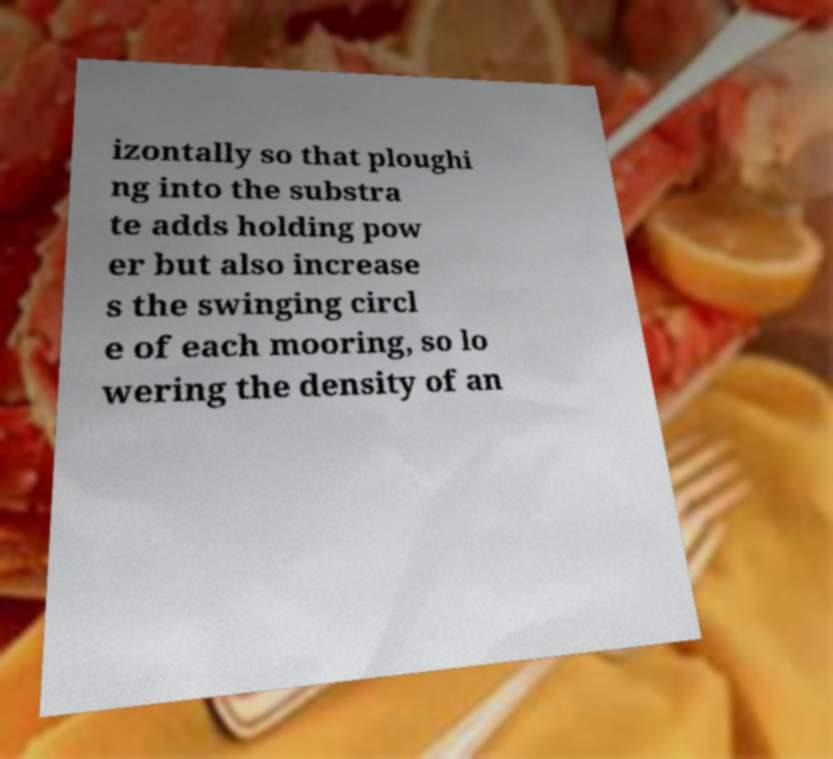For documentation purposes, I need the text within this image transcribed. Could you provide that? izontally so that ploughi ng into the substra te adds holding pow er but also increase s the swinging circl e of each mooring, so lo wering the density of an 